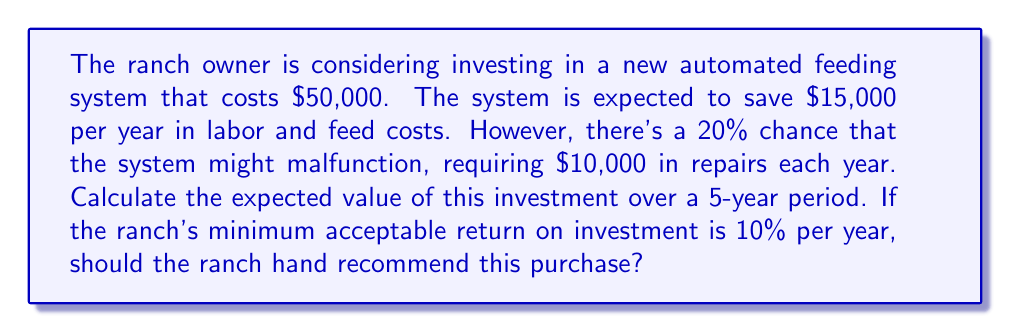Provide a solution to this math problem. To solve this problem, we need to calculate the expected value of the investment and compare it to the initial cost plus the minimum acceptable return. Let's break it down step by step:

1. Calculate the expected annual savings:
   - Annual savings without malfunction: $15,000
   - Probability of no malfunction: 80% (1 - 20%)
   - Annual cost if malfunction occurs: $10,000
   - Probability of malfunction: 20%

   Expected annual savings = $15,000 * 0.8 + ($15,000 - $10,000) * 0.2
                           = $12,000 + $1,000 = $13,000

2. Calculate the expected value over 5 years:
   Expected value = $13,000 * 5 = $65,000

3. Calculate the minimum acceptable return:
   Minimum return = $50,000 * (1 + 0.10)^5 - $50,000 ≈ $30,525

4. Compare the expected value to the initial cost plus minimum return:
   Total cost = Initial cost + Minimum return
              = $50,000 + $30,525 = $80,525

   Expected value ($65,000) < Total cost ($80,525)

5. Calculate the risk-reward ratio:
   Risk-Reward Ratio = Expected Value / Total Cost
                     = $65,000 / $80,525 ≈ 0.81

The risk-reward ratio is less than 1, indicating that the expected rewards do not outweigh the risks and costs.
Answer: The expected value of the investment over 5 years is $65,000, which is less than the total cost of $80,525 (initial investment plus minimum acceptable return). The risk-reward ratio is approximately 0.81. Therefore, the ranch hand should not recommend this purchase, as it does not meet the ranch's minimum acceptable return on investment. 